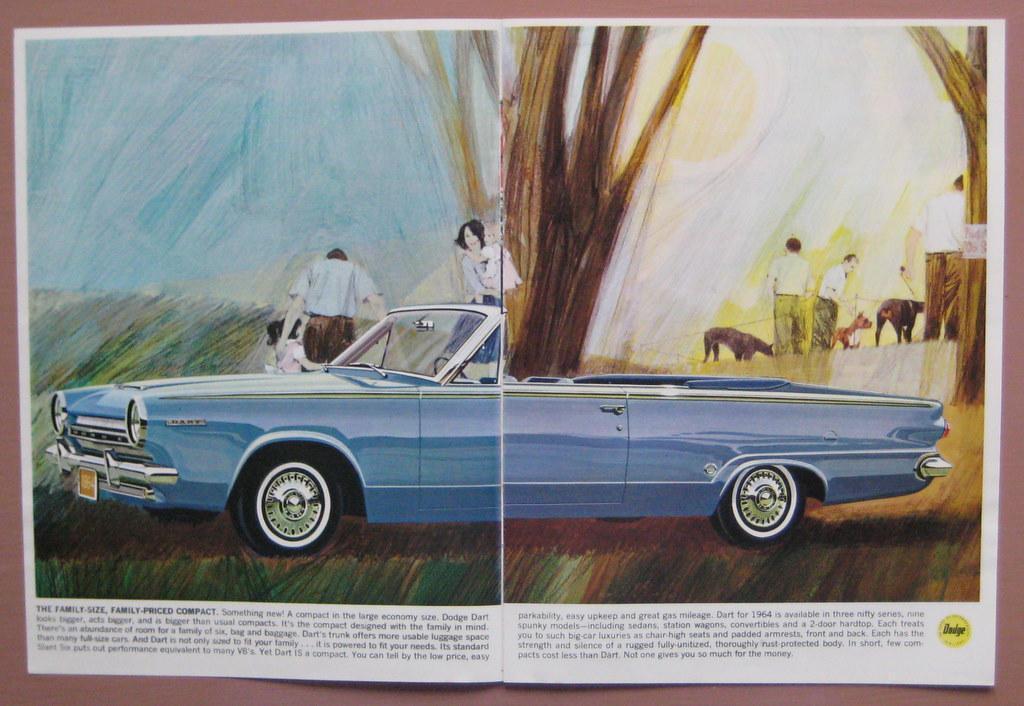Could you give a brief overview of what you see in this image? This is a page,in this page we can see persons and some text. 